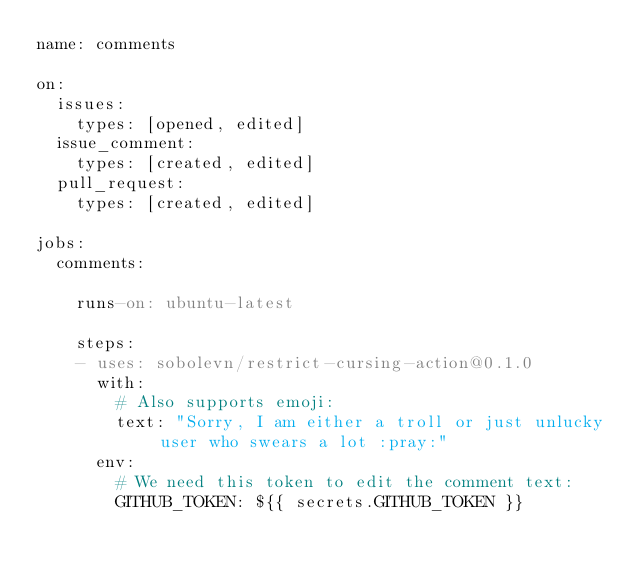<code> <loc_0><loc_0><loc_500><loc_500><_YAML_>name: comments

on:
  issues:
    types: [opened, edited]
  issue_comment:
    types: [created, edited]
  pull_request:
    types: [created, edited]

jobs:
  comments:

    runs-on: ubuntu-latest

    steps:
    - uses: sobolevn/restrict-cursing-action@0.1.0
      with:
        # Also supports emoji:
        text: "Sorry, I am either a troll or just unlucky user who swears a lot :pray:"
      env:
        # We need this token to edit the comment text:
        GITHUB_TOKEN: ${{ secrets.GITHUB_TOKEN }}
</code> 